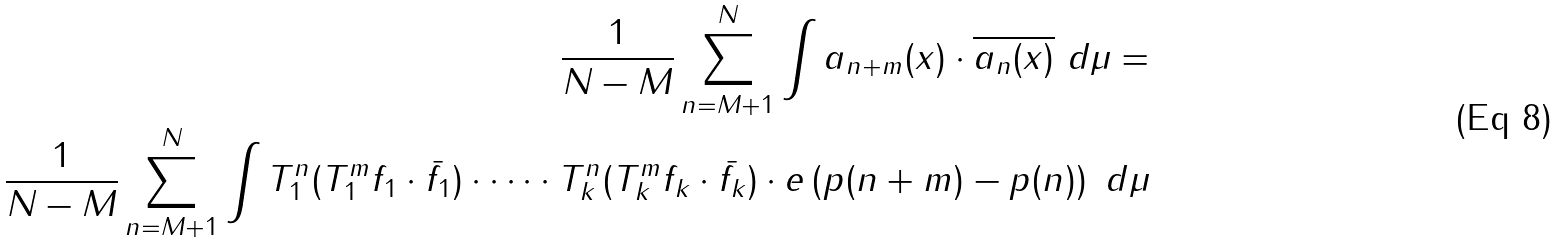Convert formula to latex. <formula><loc_0><loc_0><loc_500><loc_500>\frac { 1 } { N - M } \sum _ { n = M + 1 } ^ { N } \int a _ { n + m } ( x ) \cdot \overline { a _ { n } ( x ) } \ d \mu = \\ \frac { 1 } { N - M } \sum _ { n = M + 1 } ^ { N } \int T _ { 1 } ^ { n } ( T _ { 1 } ^ { m } f _ { 1 } \cdot \bar { f _ { 1 } } ) \cdot \dots \cdot T _ { k } ^ { n } ( T _ { k } ^ { m } f _ { k } \cdot \bar { f _ { k } } ) \cdot e \left ( p ( n + m ) - p ( n ) \right ) \ d \mu</formula> 